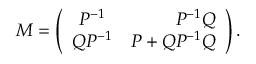<formula> <loc_0><loc_0><loc_500><loc_500>M = \left ( \begin{array} { c r c } { { P ^ { - 1 } } } & { { P ^ { - 1 } Q } } \\ { { Q P ^ { - 1 } } } & { { P + Q P ^ { - 1 } Q } } \end{array} \right ) .</formula> 